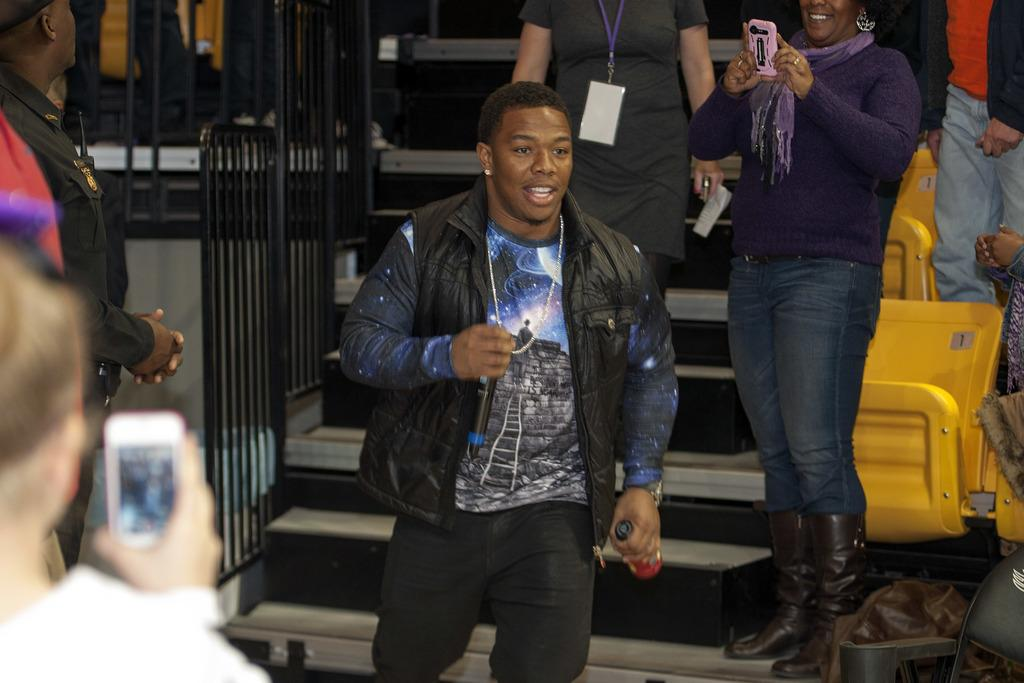What is the person in the image holding along with the mic? The person is holding a bottle in the image. What is the person doing in the image? The person is walking down stairs in the image. Are there any other people present in the image? Yes, there are people standing beside the person in the image. What are the other people holding in the image? The people standing beside the person are holding cell phones. Can you see the person in the image using a spade to dig a hole? There is no spade or hole being dug in the image; the person is holding a mic and a bottle while walking down stairs. 